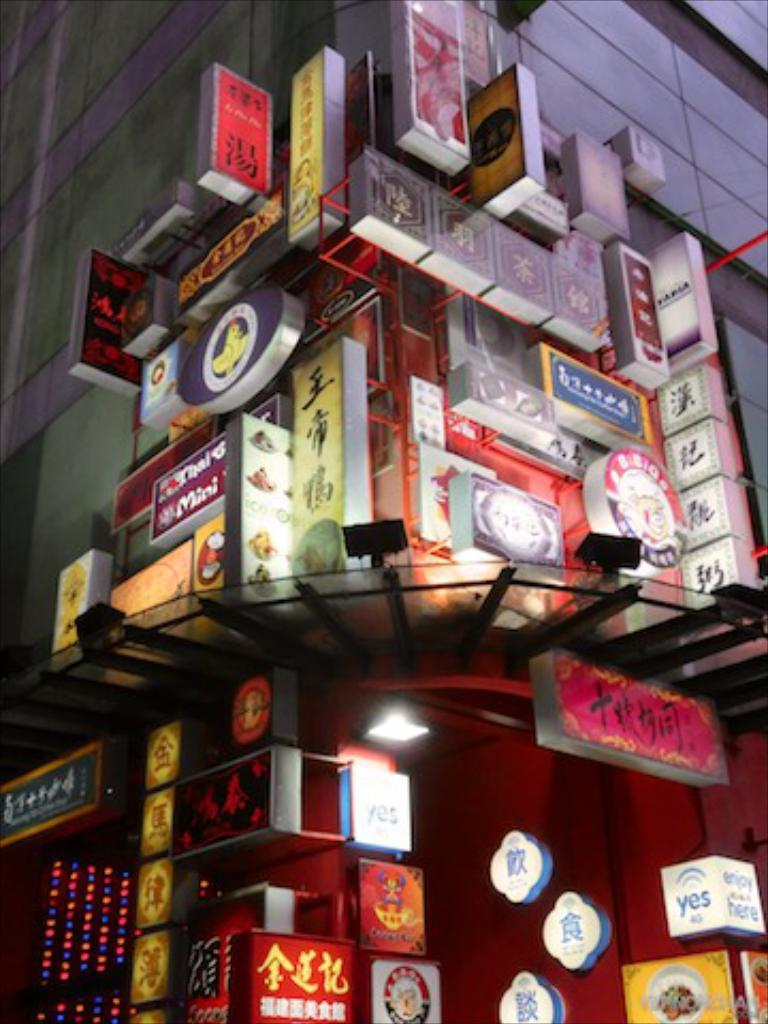What type of structure is visible in the image? There is a building in the image. What is attached to the building? There are boards and lights on the building. How much salt is present on the building in the image? There is no salt present on the building in the image. Can you see the veins of the people inside the building through the walls? There is no indication of people inside the building, and even if there were, it would not be possible to see their veins through the walls. 